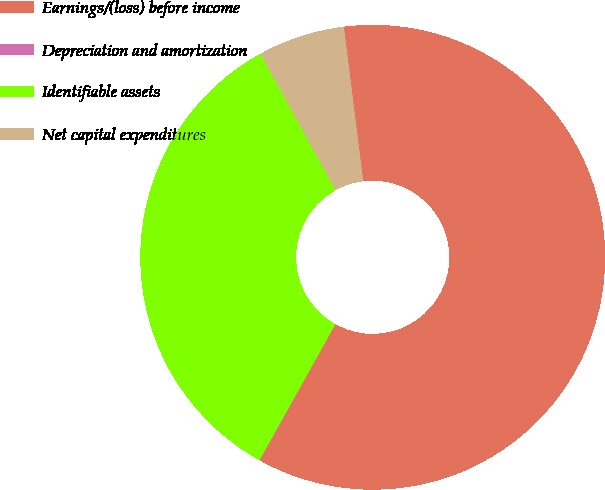Convert chart to OTSL. <chart><loc_0><loc_0><loc_500><loc_500><pie_chart><fcel>Earnings/(loss) before income<fcel>Depreciation and amortization<fcel>Identifiable assets<fcel>Net capital expenditures<nl><fcel>60.05%<fcel>0.04%<fcel>33.87%<fcel>6.04%<nl></chart> 